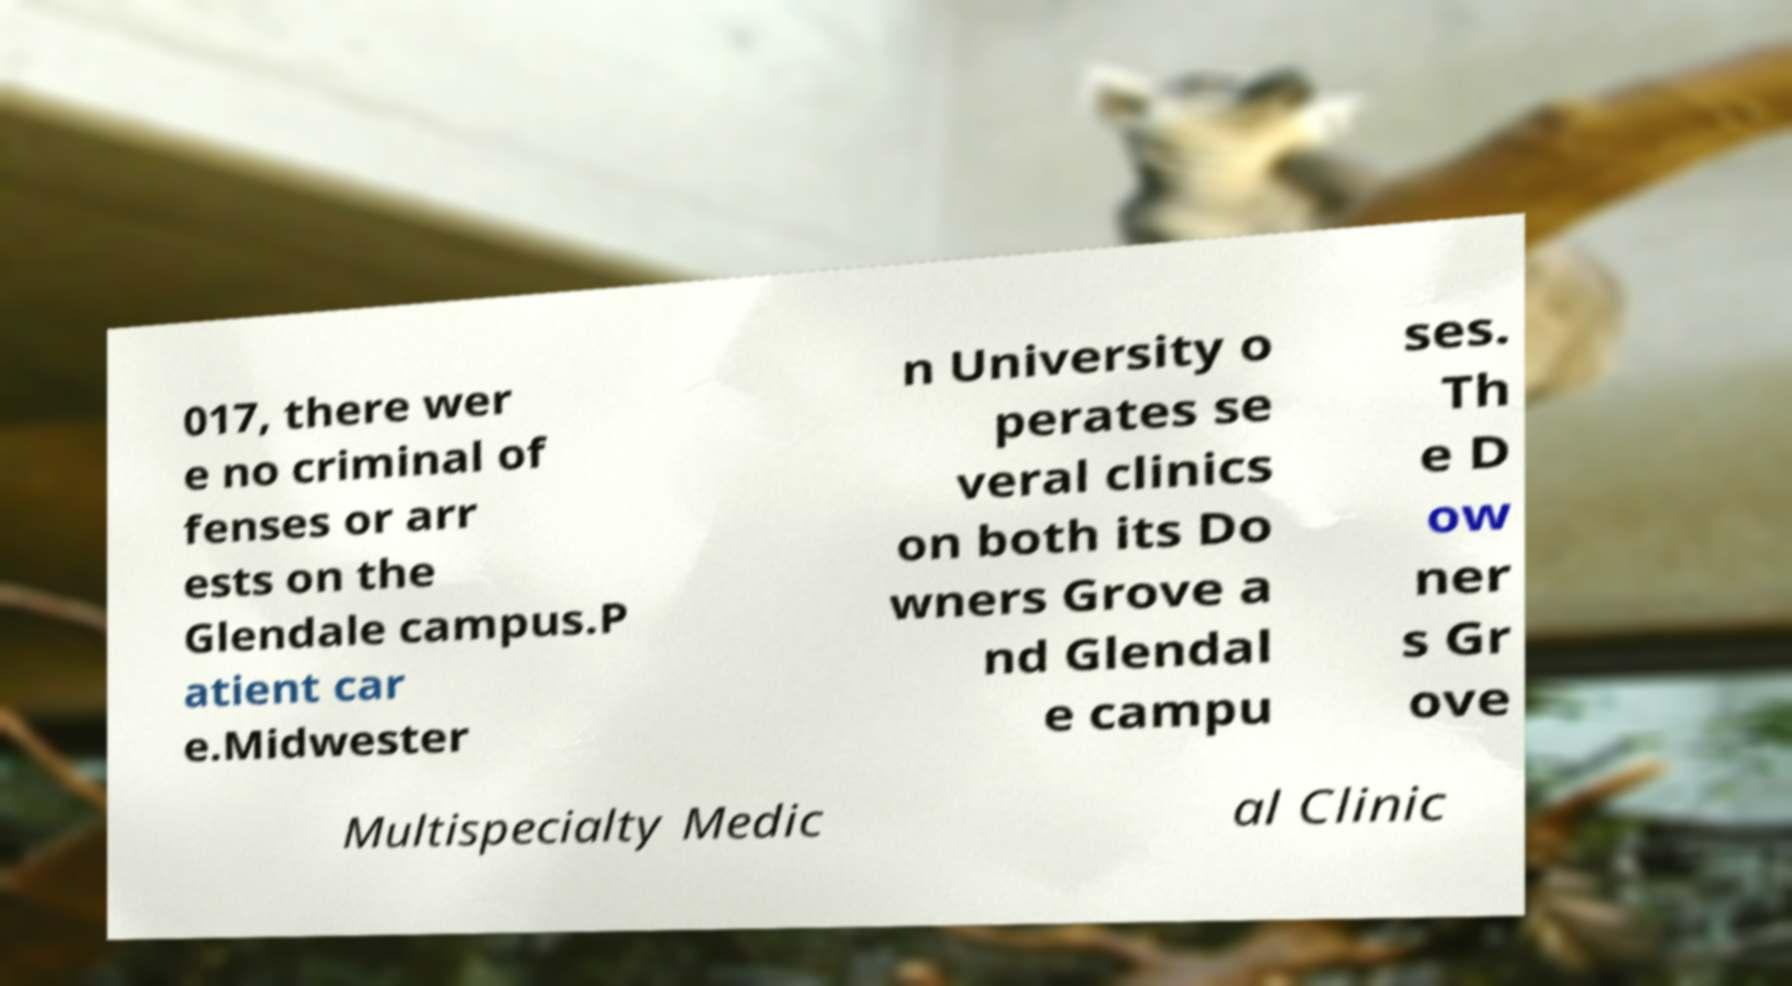What messages or text are displayed in this image? I need them in a readable, typed format. 017, there wer e no criminal of fenses or arr ests on the Glendale campus.P atient car e.Midwester n University o perates se veral clinics on both its Do wners Grove a nd Glendal e campu ses. Th e D ow ner s Gr ove Multispecialty Medic al Clinic 